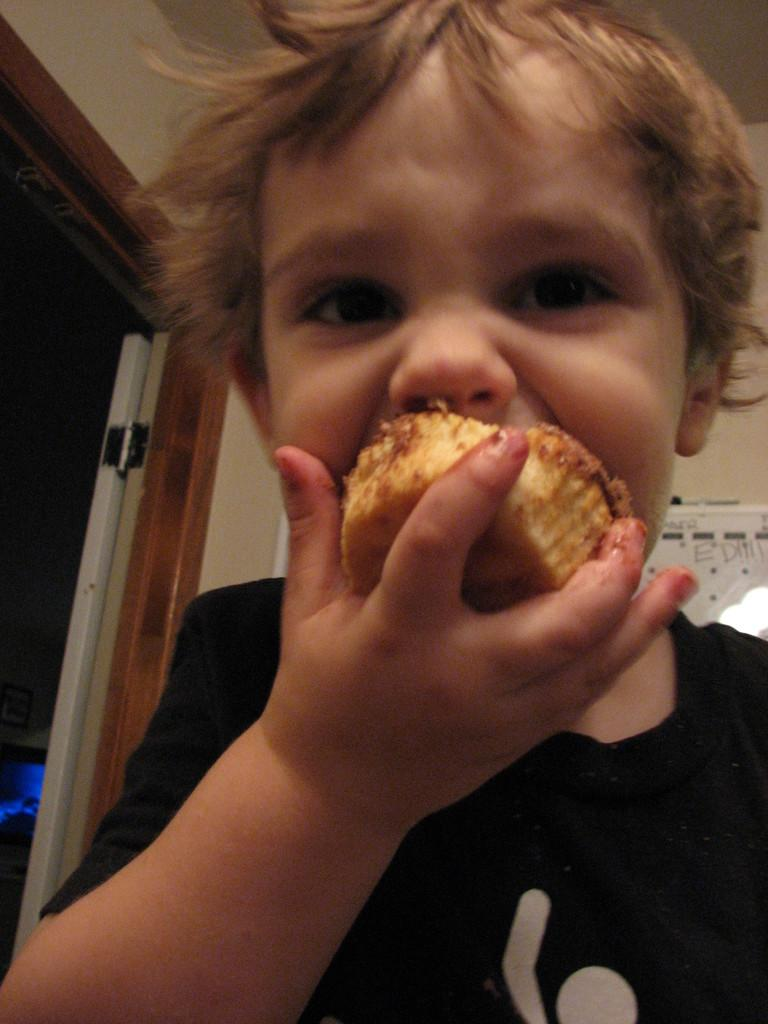Who is the main subject in the image? There is a boy in the image. What is the boy doing in the image? The boy is eating a cupcake. What can be seen on the wall in the image? There is a poster on the wall in the image. Where is the door located in the image? The door is on the left side of the image. What type of cracker is the boy using to clean the dirt off the hall floor in the image? There is no cracker or dirt present in the image, and the boy is eating a cupcake, not cleaning a hall floor. 